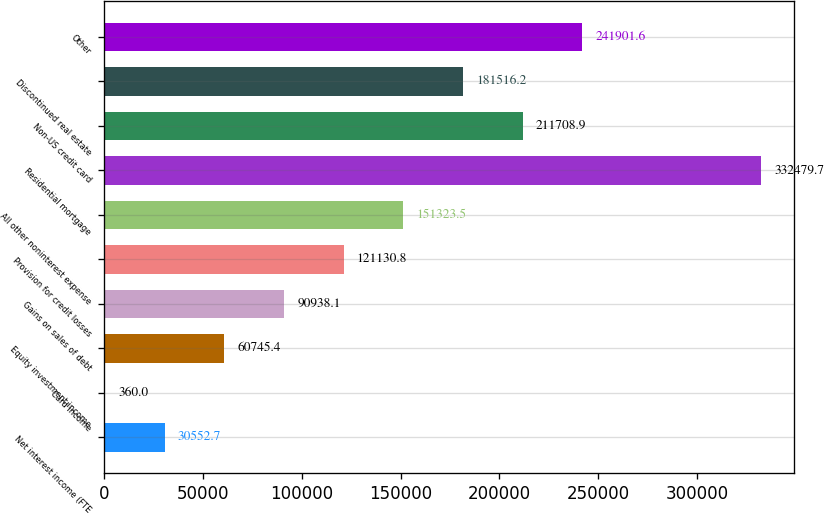<chart> <loc_0><loc_0><loc_500><loc_500><bar_chart><fcel>Net interest income (FTE<fcel>Card income<fcel>Equity investment income<fcel>Gains on sales of debt<fcel>Provision for credit losses<fcel>All other noninterest expense<fcel>Residential mortgage<fcel>Non-US credit card<fcel>Discontinued real estate<fcel>Other<nl><fcel>30552.7<fcel>360<fcel>60745.4<fcel>90938.1<fcel>121131<fcel>151324<fcel>332480<fcel>211709<fcel>181516<fcel>241902<nl></chart> 